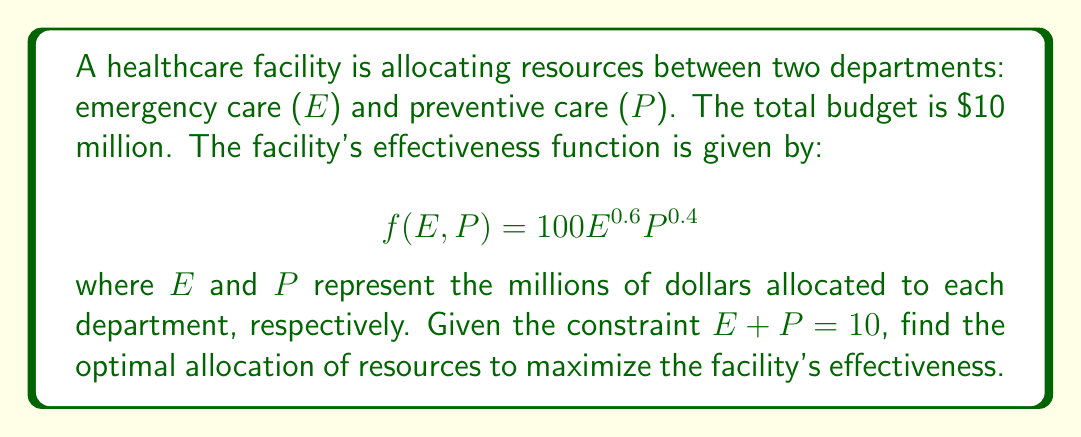Can you solve this math problem? To solve this optimization problem with a constraint, we'll use the method of Lagrange multipliers.

1) First, we set up the Lagrangian function:
   $$L(E,P,\lambda) = f(E,P) - \lambda(E + P - 10)$$
   $$L(E,P,\lambda) = 100E^{0.6}P^{0.4} - \lambda(E + P - 10)$$

2) Now, we take partial derivatives and set them equal to zero:

   $$\frac{\partial L}{\partial E} = 60E^{-0.4}P^{0.4} - \lambda = 0$$
   $$\frac{\partial L}{\partial P} = 40E^{0.6}P^{-0.6} - \lambda = 0$$
   $$\frac{\partial L}{\partial \lambda} = E + P - 10 = 0$$

3) From the first two equations:
   $$60E^{-0.4}P^{0.4} = 40E^{0.6}P^{-0.6}$$

4) Simplify:
   $$\frac{3}{2} = \frac{E}{P}$$
   $$E = \frac{3P}{2}$$

5) Substitute this into the constraint equation:
   $$\frac{3P}{2} + P = 10$$
   $$\frac{5P}{2} = 10$$
   $$P = 4$$

6) Solve for E:
   $$E = 10 - P = 6$$

7) Verify the solution satisfies the original proportion:
   $$\frac{E}{P} = \frac{6}{4} = \frac{3}{2}$$

Therefore, the optimal allocation is $6 million to emergency care and $4 million to preventive care.
Answer: Optimal allocation: $6 million to emergency care (E) and $4 million to preventive care (P). 